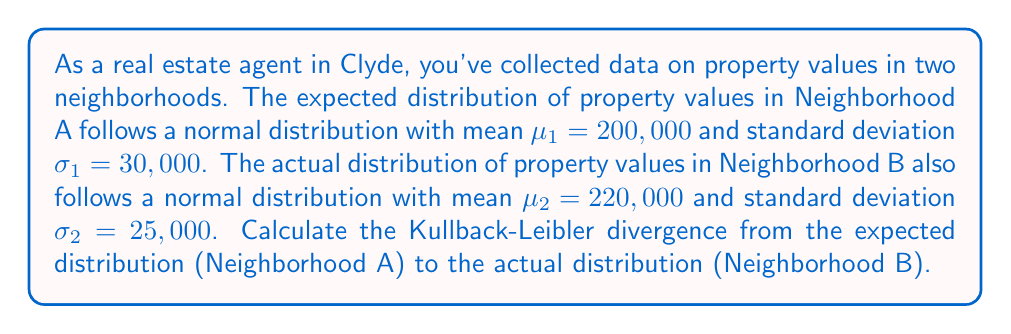Solve this math problem. To solve this problem, we'll use the formula for Kullback-Leibler (KL) divergence between two normal distributions. For two normal distributions $P \sim N(\mu_1, \sigma_1^2)$ and $Q \sim N(\mu_2, \sigma_2^2)$, the KL divergence is given by:

$$D_{KL}(P||Q) = \log\frac{\sigma_2}{\sigma_1} + \frac{\sigma_1^2 + (\mu_1 - \mu_2)^2}{2\sigma_2^2} - \frac{1}{2}$$

Let's plug in our values:
$\mu_1 = 200,000$, $\sigma_1 = 30,000$
$\mu_2 = 220,000$, $\sigma_2 = 25,000$

Now, let's calculate step by step:

1) $\log\frac{\sigma_2}{\sigma_1} = \log\frac{25,000}{30,000} = \log(0.8333) = -0.1823$

2) $\frac{\sigma_1^2 + (\mu_1 - \mu_2)^2}{2\sigma_2^2}$:
   $= \frac{30,000^2 + (200,000 - 220,000)^2}{2(25,000^2)}$
   $= \frac{900,000,000 + 400,000,000}{1,250,000,000}$
   $= \frac{1,300,000,000}{1,250,000,000} = 1.04$

3) Putting it all together:
   $D_{KL}(P||Q) = -0.1823 + 1.04 - 0.5 = 0.3577$

Therefore, the Kullback-Leibler divergence from the expected distribution to the actual distribution is approximately 0.3577.
Answer: 0.3577 